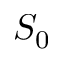<formula> <loc_0><loc_0><loc_500><loc_500>S _ { 0 }</formula> 